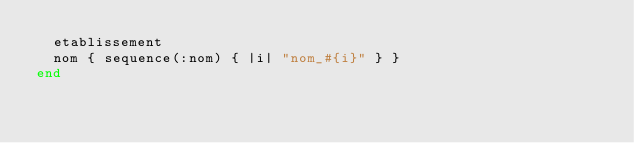Convert code to text. <code><loc_0><loc_0><loc_500><loc_500><_Ruby_>  etablissement
  nom { sequence(:nom) { |i| "nom_#{i}" } }
end
</code> 